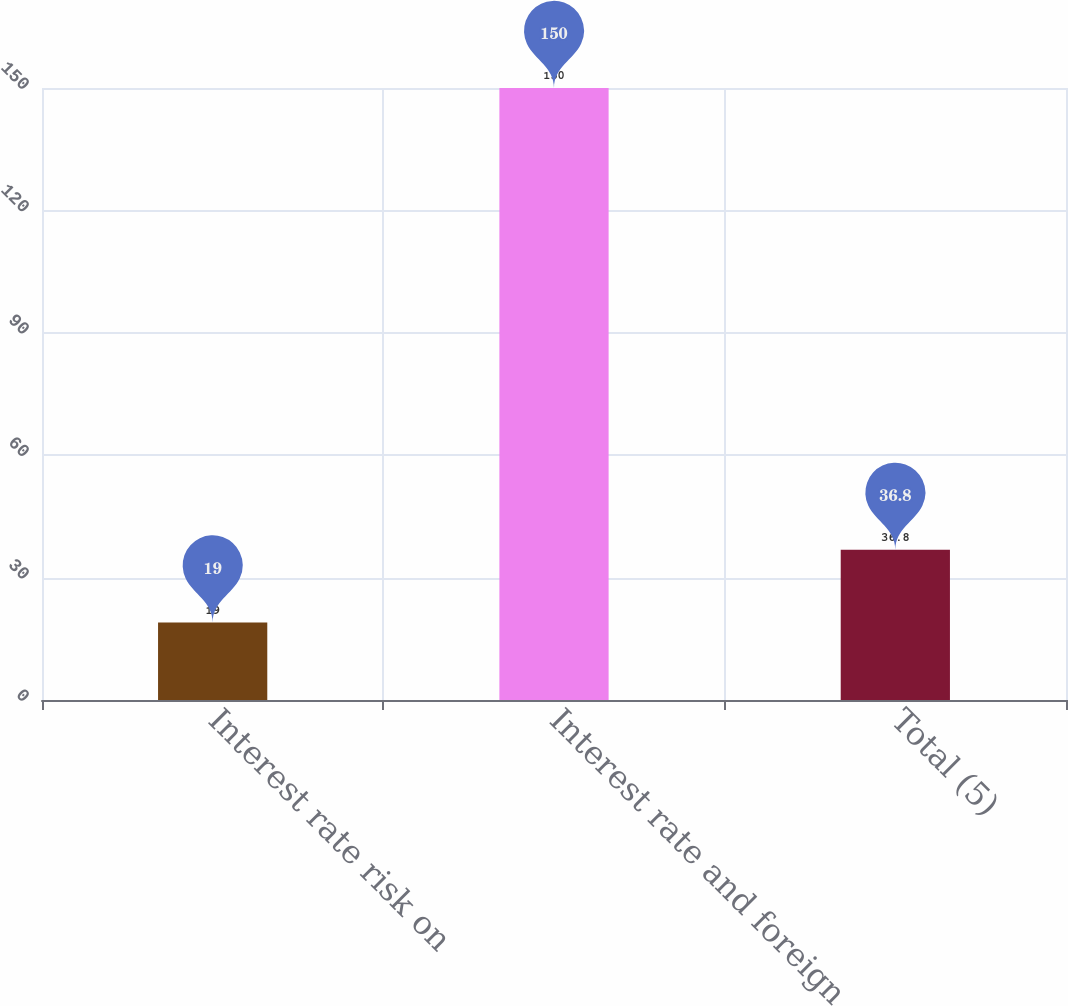Convert chart. <chart><loc_0><loc_0><loc_500><loc_500><bar_chart><fcel>Interest rate risk on<fcel>Interest rate and foreign<fcel>Total (5)<nl><fcel>19<fcel>150<fcel>36.8<nl></chart> 